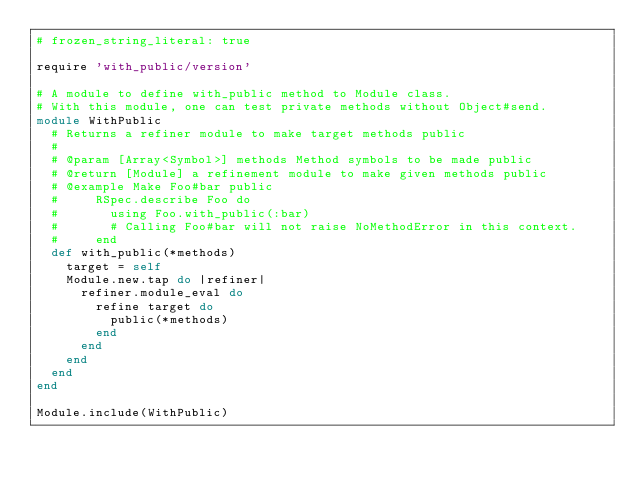<code> <loc_0><loc_0><loc_500><loc_500><_Ruby_># frozen_string_literal: true

require 'with_public/version'

# A module to define with_public method to Module class.
# With this module, one can test private methods without Object#send.
module WithPublic
  # Returns a refiner module to make target methods public
  #
  # @param [Array<Symbol>] methods Method symbols to be made public
  # @return [Module] a refinement module to make given methods public
  # @example Make Foo#bar public
  #     RSpec.describe Foo do
  #       using Foo.with_public(:bar)
  #       # Calling Foo#bar will not raise NoMethodError in this context.
  #     end
  def with_public(*methods)
    target = self
    Module.new.tap do |refiner|
      refiner.module_eval do
        refine target do
          public(*methods)
        end
      end
    end
  end
end

Module.include(WithPublic)
</code> 